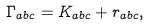<formula> <loc_0><loc_0><loc_500><loc_500>\Gamma _ { a b c } = K _ { a b c } + r _ { a b c } ,</formula> 